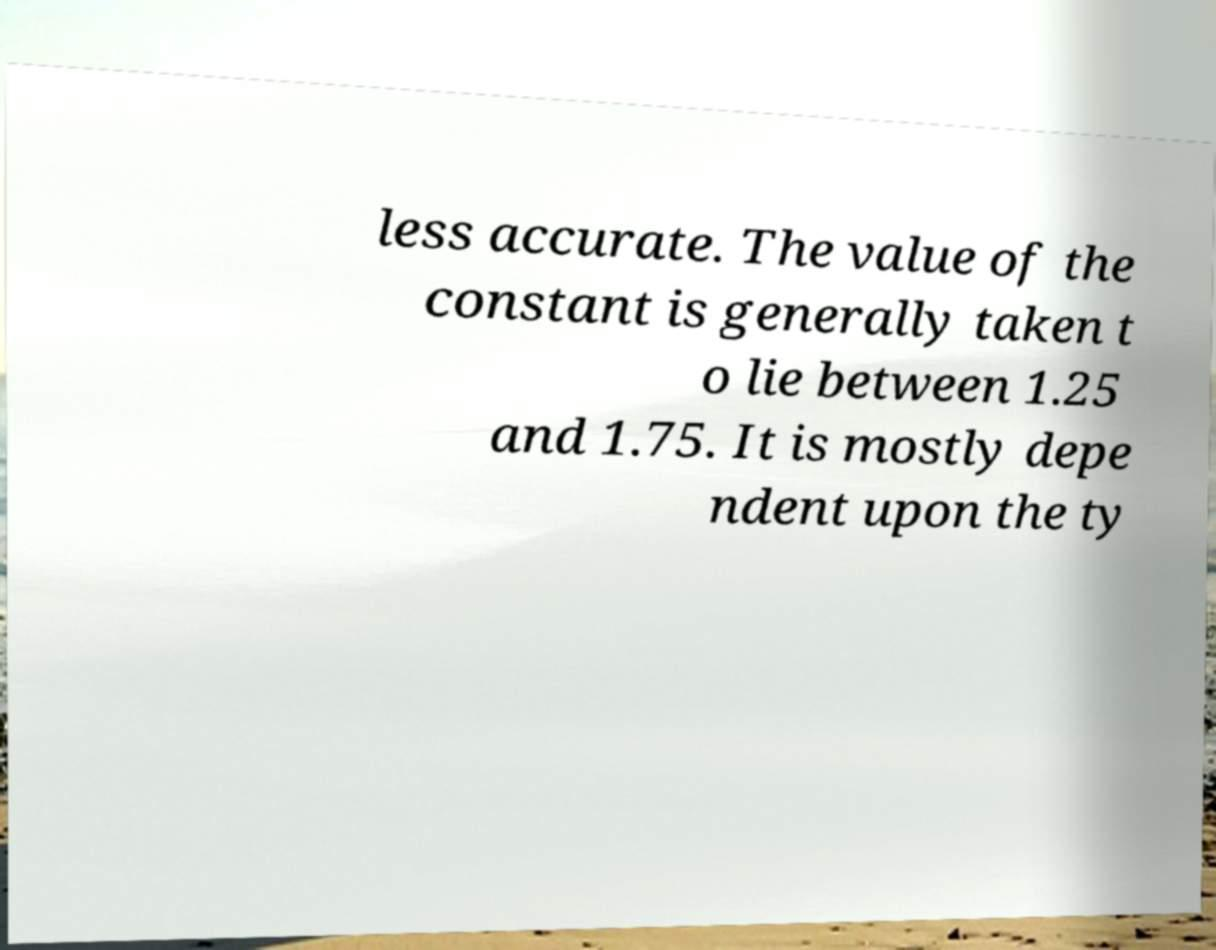Please read and relay the text visible in this image. What does it say? less accurate. The value of the constant is generally taken t o lie between 1.25 and 1.75. It is mostly depe ndent upon the ty 